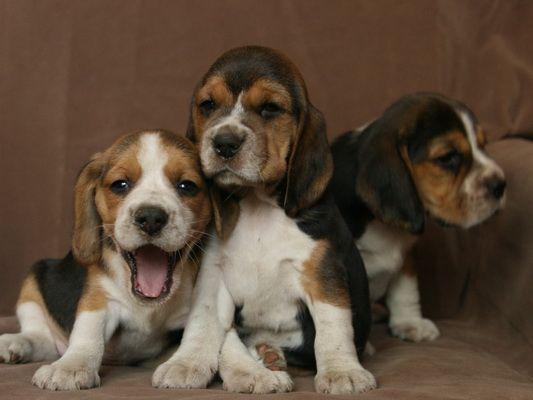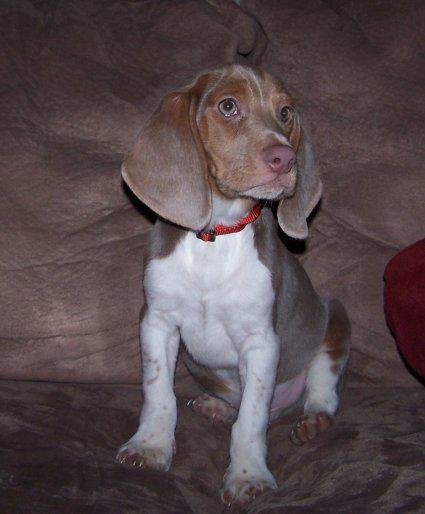The first image is the image on the left, the second image is the image on the right. Assess this claim about the two images: "Each image contains one hound dog posing on furniture, and at least one dog is on leather upholstery.". Correct or not? Answer yes or no. No. The first image is the image on the left, the second image is the image on the right. Evaluate the accuracy of this statement regarding the images: "The dog in one of the images has a red collar.". Is it true? Answer yes or no. Yes. 